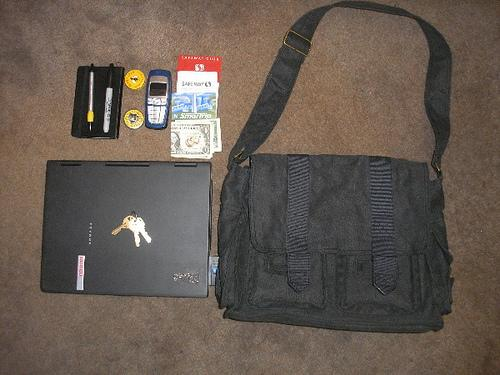What is on the laptop? keys 